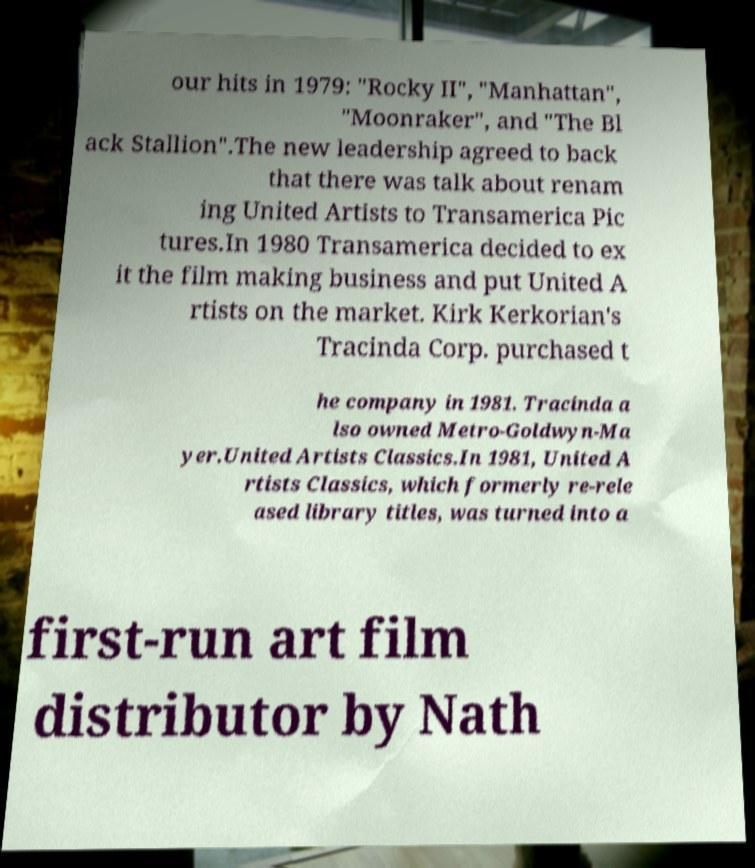Please identify and transcribe the text found in this image. our hits in 1979: "Rocky II", "Manhattan", "Moonraker", and "The Bl ack Stallion".The new leadership agreed to back that there was talk about renam ing United Artists to Transamerica Pic tures.In 1980 Transamerica decided to ex it the film making business and put United A rtists on the market. Kirk Kerkorian's Tracinda Corp. purchased t he company in 1981. Tracinda a lso owned Metro-Goldwyn-Ma yer.United Artists Classics.In 1981, United A rtists Classics, which formerly re-rele ased library titles, was turned into a first-run art film distributor by Nath 